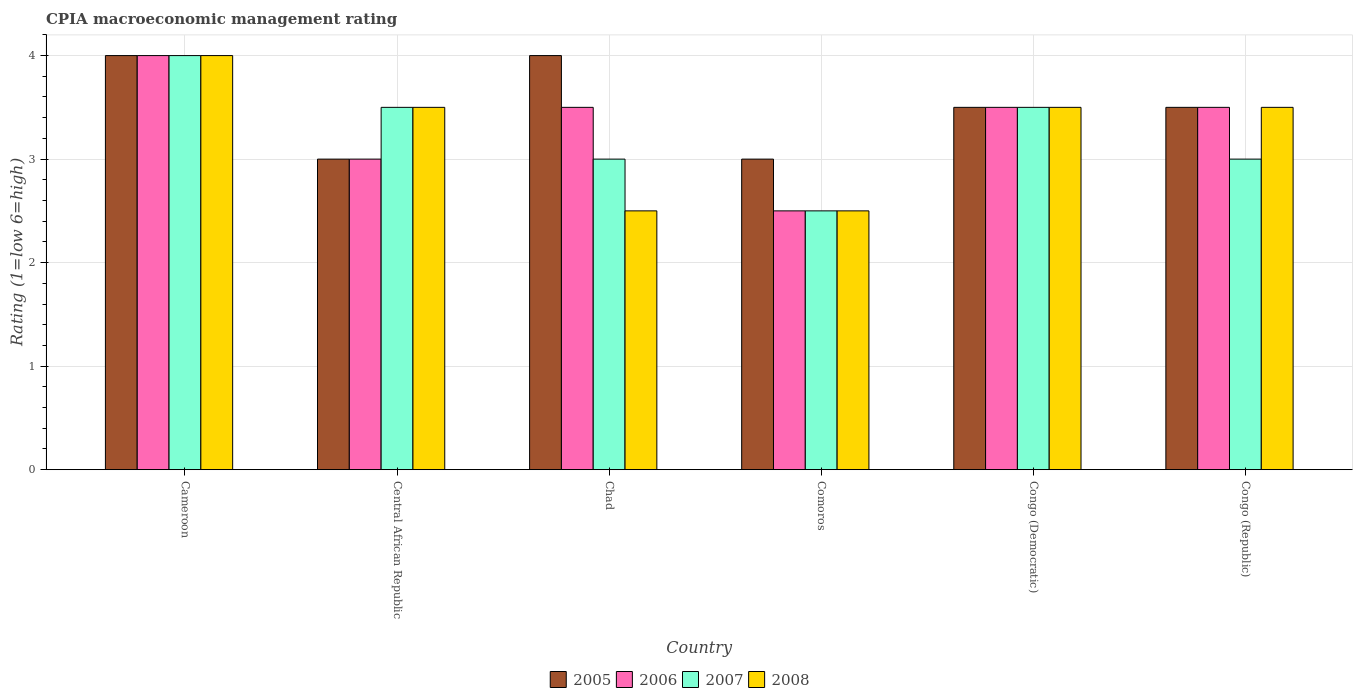How many different coloured bars are there?
Offer a very short reply. 4. Are the number of bars per tick equal to the number of legend labels?
Your answer should be compact. Yes. How many bars are there on the 1st tick from the right?
Offer a very short reply. 4. What is the label of the 3rd group of bars from the left?
Keep it short and to the point. Chad. In how many cases, is the number of bars for a given country not equal to the number of legend labels?
Offer a terse response. 0. What is the CPIA rating in 2006 in Congo (Democratic)?
Provide a short and direct response. 3.5. Across all countries, what is the minimum CPIA rating in 2006?
Provide a succinct answer. 2.5. In which country was the CPIA rating in 2007 maximum?
Give a very brief answer. Cameroon. In which country was the CPIA rating in 2005 minimum?
Your answer should be compact. Central African Republic. What is the total CPIA rating in 2007 in the graph?
Make the answer very short. 19.5. What is the difference between the CPIA rating in 2008 in Cameroon and that in Chad?
Provide a succinct answer. 1.5. What is the difference between the CPIA rating of/in 2008 and CPIA rating of/in 2006 in Central African Republic?
Your answer should be very brief. 0.5. In how many countries, is the CPIA rating in 2006 greater than 2.2?
Keep it short and to the point. 6. What is the ratio of the CPIA rating in 2007 in Chad to that in Congo (Democratic)?
Your response must be concise. 0.86. Is the CPIA rating in 2006 in Chad less than that in Congo (Democratic)?
Make the answer very short. No. What is the difference between the highest and the second highest CPIA rating in 2007?
Offer a very short reply. -0.5. What is the difference between the highest and the lowest CPIA rating in 2005?
Your response must be concise. 1. Is the sum of the CPIA rating in 2007 in Chad and Congo (Democratic) greater than the maximum CPIA rating in 2005 across all countries?
Provide a succinct answer. Yes. How many bars are there?
Give a very brief answer. 24. Are all the bars in the graph horizontal?
Make the answer very short. No. What is the difference between two consecutive major ticks on the Y-axis?
Provide a short and direct response. 1. Does the graph contain grids?
Give a very brief answer. Yes. How are the legend labels stacked?
Make the answer very short. Horizontal. What is the title of the graph?
Make the answer very short. CPIA macroeconomic management rating. What is the Rating (1=low 6=high) of 2008 in Cameroon?
Provide a short and direct response. 4. What is the Rating (1=low 6=high) of 2007 in Central African Republic?
Provide a succinct answer. 3.5. What is the Rating (1=low 6=high) of 2008 in Chad?
Provide a short and direct response. 2.5. What is the Rating (1=low 6=high) of 2008 in Comoros?
Your response must be concise. 2.5. What is the Rating (1=low 6=high) in 2006 in Congo (Democratic)?
Provide a succinct answer. 3.5. What is the Rating (1=low 6=high) in 2007 in Congo (Democratic)?
Offer a very short reply. 3.5. What is the Rating (1=low 6=high) of 2005 in Congo (Republic)?
Offer a terse response. 3.5. What is the Rating (1=low 6=high) in 2006 in Congo (Republic)?
Provide a succinct answer. 3.5. Across all countries, what is the maximum Rating (1=low 6=high) in 2005?
Keep it short and to the point. 4. Across all countries, what is the maximum Rating (1=low 6=high) in 2007?
Give a very brief answer. 4. Across all countries, what is the maximum Rating (1=low 6=high) of 2008?
Give a very brief answer. 4. Across all countries, what is the minimum Rating (1=low 6=high) in 2008?
Your answer should be compact. 2.5. What is the total Rating (1=low 6=high) in 2005 in the graph?
Provide a succinct answer. 21. What is the total Rating (1=low 6=high) in 2006 in the graph?
Make the answer very short. 20. What is the total Rating (1=low 6=high) in 2007 in the graph?
Your response must be concise. 19.5. What is the difference between the Rating (1=low 6=high) of 2005 in Cameroon and that in Central African Republic?
Ensure brevity in your answer.  1. What is the difference between the Rating (1=low 6=high) of 2007 in Cameroon and that in Central African Republic?
Your answer should be very brief. 0.5. What is the difference between the Rating (1=low 6=high) of 2008 in Cameroon and that in Central African Republic?
Ensure brevity in your answer.  0.5. What is the difference between the Rating (1=low 6=high) of 2005 in Cameroon and that in Comoros?
Offer a very short reply. 1. What is the difference between the Rating (1=low 6=high) in 2008 in Cameroon and that in Comoros?
Ensure brevity in your answer.  1.5. What is the difference between the Rating (1=low 6=high) of 2005 in Cameroon and that in Congo (Democratic)?
Offer a very short reply. 0.5. What is the difference between the Rating (1=low 6=high) of 2006 in Cameroon and that in Congo (Democratic)?
Give a very brief answer. 0.5. What is the difference between the Rating (1=low 6=high) of 2007 in Cameroon and that in Congo (Democratic)?
Your response must be concise. 0.5. What is the difference between the Rating (1=low 6=high) of 2008 in Cameroon and that in Congo (Democratic)?
Provide a short and direct response. 0.5. What is the difference between the Rating (1=low 6=high) in 2005 in Cameroon and that in Congo (Republic)?
Keep it short and to the point. 0.5. What is the difference between the Rating (1=low 6=high) of 2008 in Cameroon and that in Congo (Republic)?
Provide a succinct answer. 0.5. What is the difference between the Rating (1=low 6=high) in 2006 in Central African Republic and that in Chad?
Offer a very short reply. -0.5. What is the difference between the Rating (1=low 6=high) of 2008 in Central African Republic and that in Chad?
Make the answer very short. 1. What is the difference between the Rating (1=low 6=high) in 2007 in Central African Republic and that in Comoros?
Provide a succinct answer. 1. What is the difference between the Rating (1=low 6=high) in 2007 in Central African Republic and that in Congo (Democratic)?
Give a very brief answer. 0. What is the difference between the Rating (1=low 6=high) of 2008 in Central African Republic and that in Congo (Democratic)?
Offer a terse response. 0. What is the difference between the Rating (1=low 6=high) of 2005 in Central African Republic and that in Congo (Republic)?
Provide a succinct answer. -0.5. What is the difference between the Rating (1=low 6=high) in 2005 in Chad and that in Comoros?
Make the answer very short. 1. What is the difference between the Rating (1=low 6=high) of 2007 in Chad and that in Comoros?
Ensure brevity in your answer.  0.5. What is the difference between the Rating (1=low 6=high) of 2008 in Chad and that in Comoros?
Your answer should be very brief. 0. What is the difference between the Rating (1=low 6=high) of 2005 in Chad and that in Congo (Democratic)?
Provide a short and direct response. 0.5. What is the difference between the Rating (1=low 6=high) in 2007 in Chad and that in Congo (Democratic)?
Offer a terse response. -0.5. What is the difference between the Rating (1=low 6=high) of 2008 in Chad and that in Congo (Democratic)?
Give a very brief answer. -1. What is the difference between the Rating (1=low 6=high) of 2005 in Chad and that in Congo (Republic)?
Offer a very short reply. 0.5. What is the difference between the Rating (1=low 6=high) of 2007 in Chad and that in Congo (Republic)?
Your answer should be very brief. 0. What is the difference between the Rating (1=low 6=high) in 2008 in Chad and that in Congo (Republic)?
Offer a very short reply. -1. What is the difference between the Rating (1=low 6=high) in 2007 in Comoros and that in Congo (Democratic)?
Keep it short and to the point. -1. What is the difference between the Rating (1=low 6=high) in 2008 in Comoros and that in Congo (Democratic)?
Your answer should be compact. -1. What is the difference between the Rating (1=low 6=high) in 2005 in Comoros and that in Congo (Republic)?
Offer a very short reply. -0.5. What is the difference between the Rating (1=low 6=high) of 2007 in Comoros and that in Congo (Republic)?
Ensure brevity in your answer.  -0.5. What is the difference between the Rating (1=low 6=high) in 2005 in Cameroon and the Rating (1=low 6=high) in 2006 in Central African Republic?
Provide a short and direct response. 1. What is the difference between the Rating (1=low 6=high) of 2005 in Cameroon and the Rating (1=low 6=high) of 2007 in Central African Republic?
Ensure brevity in your answer.  0.5. What is the difference between the Rating (1=low 6=high) of 2006 in Cameroon and the Rating (1=low 6=high) of 2008 in Central African Republic?
Offer a terse response. 0.5. What is the difference between the Rating (1=low 6=high) in 2007 in Cameroon and the Rating (1=low 6=high) in 2008 in Central African Republic?
Keep it short and to the point. 0.5. What is the difference between the Rating (1=low 6=high) in 2005 in Cameroon and the Rating (1=low 6=high) in 2007 in Chad?
Your answer should be compact. 1. What is the difference between the Rating (1=low 6=high) in 2005 in Cameroon and the Rating (1=low 6=high) in 2008 in Chad?
Offer a terse response. 1.5. What is the difference between the Rating (1=low 6=high) of 2006 in Cameroon and the Rating (1=low 6=high) of 2007 in Chad?
Your answer should be very brief. 1. What is the difference between the Rating (1=low 6=high) of 2005 in Cameroon and the Rating (1=low 6=high) of 2006 in Comoros?
Offer a very short reply. 1.5. What is the difference between the Rating (1=low 6=high) of 2005 in Cameroon and the Rating (1=low 6=high) of 2007 in Comoros?
Provide a succinct answer. 1.5. What is the difference between the Rating (1=low 6=high) in 2005 in Cameroon and the Rating (1=low 6=high) in 2007 in Congo (Democratic)?
Offer a terse response. 0.5. What is the difference between the Rating (1=low 6=high) in 2006 in Cameroon and the Rating (1=low 6=high) in 2007 in Congo (Democratic)?
Provide a short and direct response. 0.5. What is the difference between the Rating (1=low 6=high) in 2006 in Cameroon and the Rating (1=low 6=high) in 2008 in Congo (Democratic)?
Keep it short and to the point. 0.5. What is the difference between the Rating (1=low 6=high) of 2007 in Cameroon and the Rating (1=low 6=high) of 2008 in Congo (Democratic)?
Ensure brevity in your answer.  0.5. What is the difference between the Rating (1=low 6=high) in 2005 in Cameroon and the Rating (1=low 6=high) in 2006 in Congo (Republic)?
Make the answer very short. 0.5. What is the difference between the Rating (1=low 6=high) of 2005 in Cameroon and the Rating (1=low 6=high) of 2007 in Congo (Republic)?
Ensure brevity in your answer.  1. What is the difference between the Rating (1=low 6=high) in 2006 in Cameroon and the Rating (1=low 6=high) in 2007 in Congo (Republic)?
Make the answer very short. 1. What is the difference between the Rating (1=low 6=high) of 2007 in Cameroon and the Rating (1=low 6=high) of 2008 in Congo (Republic)?
Offer a very short reply. 0.5. What is the difference between the Rating (1=low 6=high) of 2005 in Central African Republic and the Rating (1=low 6=high) of 2006 in Chad?
Give a very brief answer. -0.5. What is the difference between the Rating (1=low 6=high) of 2005 in Central African Republic and the Rating (1=low 6=high) of 2007 in Chad?
Keep it short and to the point. 0. What is the difference between the Rating (1=low 6=high) of 2005 in Central African Republic and the Rating (1=low 6=high) of 2008 in Chad?
Make the answer very short. 0.5. What is the difference between the Rating (1=low 6=high) of 2006 in Central African Republic and the Rating (1=low 6=high) of 2007 in Chad?
Provide a short and direct response. 0. What is the difference between the Rating (1=low 6=high) in 2006 in Central African Republic and the Rating (1=low 6=high) in 2008 in Chad?
Your answer should be very brief. 0.5. What is the difference between the Rating (1=low 6=high) of 2007 in Central African Republic and the Rating (1=low 6=high) of 2008 in Chad?
Your answer should be very brief. 1. What is the difference between the Rating (1=low 6=high) in 2005 in Central African Republic and the Rating (1=low 6=high) in 2006 in Comoros?
Ensure brevity in your answer.  0.5. What is the difference between the Rating (1=low 6=high) of 2005 in Central African Republic and the Rating (1=low 6=high) of 2008 in Comoros?
Give a very brief answer. 0.5. What is the difference between the Rating (1=low 6=high) in 2006 in Central African Republic and the Rating (1=low 6=high) in 2007 in Comoros?
Provide a succinct answer. 0.5. What is the difference between the Rating (1=low 6=high) of 2007 in Central African Republic and the Rating (1=low 6=high) of 2008 in Comoros?
Offer a very short reply. 1. What is the difference between the Rating (1=low 6=high) of 2005 in Central African Republic and the Rating (1=low 6=high) of 2006 in Congo (Democratic)?
Give a very brief answer. -0.5. What is the difference between the Rating (1=low 6=high) of 2005 in Central African Republic and the Rating (1=low 6=high) of 2007 in Congo (Democratic)?
Offer a very short reply. -0.5. What is the difference between the Rating (1=low 6=high) in 2005 in Central African Republic and the Rating (1=low 6=high) in 2008 in Congo (Democratic)?
Your answer should be compact. -0.5. What is the difference between the Rating (1=low 6=high) of 2006 in Central African Republic and the Rating (1=low 6=high) of 2008 in Congo (Democratic)?
Provide a succinct answer. -0.5. What is the difference between the Rating (1=low 6=high) in 2005 in Central African Republic and the Rating (1=low 6=high) in 2008 in Congo (Republic)?
Give a very brief answer. -0.5. What is the difference between the Rating (1=low 6=high) in 2007 in Central African Republic and the Rating (1=low 6=high) in 2008 in Congo (Republic)?
Ensure brevity in your answer.  0. What is the difference between the Rating (1=low 6=high) in 2005 in Chad and the Rating (1=low 6=high) in 2006 in Congo (Republic)?
Keep it short and to the point. 0.5. What is the difference between the Rating (1=low 6=high) in 2005 in Chad and the Rating (1=low 6=high) in 2007 in Congo (Republic)?
Offer a terse response. 1. What is the difference between the Rating (1=low 6=high) in 2005 in Chad and the Rating (1=low 6=high) in 2008 in Congo (Republic)?
Ensure brevity in your answer.  0.5. What is the difference between the Rating (1=low 6=high) of 2006 in Chad and the Rating (1=low 6=high) of 2007 in Congo (Republic)?
Your answer should be very brief. 0.5. What is the difference between the Rating (1=low 6=high) of 2007 in Chad and the Rating (1=low 6=high) of 2008 in Congo (Republic)?
Give a very brief answer. -0.5. What is the difference between the Rating (1=low 6=high) in 2005 in Comoros and the Rating (1=low 6=high) in 2008 in Congo (Democratic)?
Your response must be concise. -0.5. What is the difference between the Rating (1=low 6=high) of 2006 in Comoros and the Rating (1=low 6=high) of 2008 in Congo (Democratic)?
Provide a succinct answer. -1. What is the difference between the Rating (1=low 6=high) of 2005 in Comoros and the Rating (1=low 6=high) of 2006 in Congo (Republic)?
Your answer should be compact. -0.5. What is the difference between the Rating (1=low 6=high) in 2005 in Comoros and the Rating (1=low 6=high) in 2007 in Congo (Republic)?
Make the answer very short. 0. What is the difference between the Rating (1=low 6=high) in 2006 in Comoros and the Rating (1=low 6=high) in 2007 in Congo (Republic)?
Offer a very short reply. -0.5. What is the difference between the Rating (1=low 6=high) in 2006 in Comoros and the Rating (1=low 6=high) in 2008 in Congo (Republic)?
Provide a succinct answer. -1. What is the difference between the Rating (1=low 6=high) of 2005 in Congo (Democratic) and the Rating (1=low 6=high) of 2008 in Congo (Republic)?
Your response must be concise. 0. What is the difference between the Rating (1=low 6=high) of 2007 in Congo (Democratic) and the Rating (1=low 6=high) of 2008 in Congo (Republic)?
Offer a terse response. 0. What is the average Rating (1=low 6=high) in 2005 per country?
Give a very brief answer. 3.5. What is the average Rating (1=low 6=high) in 2006 per country?
Ensure brevity in your answer.  3.33. What is the average Rating (1=low 6=high) of 2007 per country?
Your response must be concise. 3.25. What is the average Rating (1=low 6=high) in 2008 per country?
Keep it short and to the point. 3.25. What is the difference between the Rating (1=low 6=high) of 2005 and Rating (1=low 6=high) of 2007 in Cameroon?
Give a very brief answer. 0. What is the difference between the Rating (1=low 6=high) of 2006 and Rating (1=low 6=high) of 2008 in Cameroon?
Provide a short and direct response. 0. What is the difference between the Rating (1=low 6=high) in 2007 and Rating (1=low 6=high) in 2008 in Cameroon?
Give a very brief answer. 0. What is the difference between the Rating (1=low 6=high) of 2006 and Rating (1=low 6=high) of 2008 in Central African Republic?
Your response must be concise. -0.5. What is the difference between the Rating (1=low 6=high) in 2007 and Rating (1=low 6=high) in 2008 in Central African Republic?
Offer a very short reply. 0. What is the difference between the Rating (1=low 6=high) in 2005 and Rating (1=low 6=high) in 2006 in Chad?
Offer a very short reply. 0.5. What is the difference between the Rating (1=low 6=high) in 2005 and Rating (1=low 6=high) in 2007 in Chad?
Offer a terse response. 1. What is the difference between the Rating (1=low 6=high) in 2005 and Rating (1=low 6=high) in 2008 in Chad?
Provide a short and direct response. 1.5. What is the difference between the Rating (1=low 6=high) of 2006 and Rating (1=low 6=high) of 2007 in Chad?
Your answer should be very brief. 0.5. What is the difference between the Rating (1=low 6=high) in 2006 and Rating (1=low 6=high) in 2008 in Chad?
Make the answer very short. 1. What is the difference between the Rating (1=low 6=high) of 2007 and Rating (1=low 6=high) of 2008 in Chad?
Ensure brevity in your answer.  0.5. What is the difference between the Rating (1=low 6=high) in 2005 and Rating (1=low 6=high) in 2006 in Comoros?
Keep it short and to the point. 0.5. What is the difference between the Rating (1=low 6=high) in 2005 and Rating (1=low 6=high) in 2007 in Comoros?
Your answer should be compact. 0.5. What is the difference between the Rating (1=low 6=high) in 2006 and Rating (1=low 6=high) in 2008 in Comoros?
Give a very brief answer. 0. What is the difference between the Rating (1=low 6=high) of 2007 and Rating (1=low 6=high) of 2008 in Comoros?
Offer a terse response. 0. What is the difference between the Rating (1=low 6=high) of 2005 and Rating (1=low 6=high) of 2008 in Congo (Democratic)?
Offer a very short reply. 0. What is the difference between the Rating (1=low 6=high) of 2006 and Rating (1=low 6=high) of 2007 in Congo (Democratic)?
Offer a very short reply. 0. What is the difference between the Rating (1=low 6=high) of 2006 and Rating (1=low 6=high) of 2008 in Congo (Democratic)?
Give a very brief answer. 0. What is the difference between the Rating (1=low 6=high) of 2005 and Rating (1=low 6=high) of 2007 in Congo (Republic)?
Your response must be concise. 0.5. What is the difference between the Rating (1=low 6=high) in 2006 and Rating (1=low 6=high) in 2008 in Congo (Republic)?
Offer a terse response. 0. What is the difference between the Rating (1=low 6=high) in 2007 and Rating (1=low 6=high) in 2008 in Congo (Republic)?
Keep it short and to the point. -0.5. What is the ratio of the Rating (1=low 6=high) in 2006 in Cameroon to that in Central African Republic?
Your answer should be compact. 1.33. What is the ratio of the Rating (1=low 6=high) in 2006 in Cameroon to that in Chad?
Make the answer very short. 1.14. What is the ratio of the Rating (1=low 6=high) in 2005 in Cameroon to that in Comoros?
Provide a short and direct response. 1.33. What is the ratio of the Rating (1=low 6=high) of 2008 in Cameroon to that in Comoros?
Make the answer very short. 1.6. What is the ratio of the Rating (1=low 6=high) in 2005 in Cameroon to that in Congo (Democratic)?
Provide a short and direct response. 1.14. What is the ratio of the Rating (1=low 6=high) of 2006 in Cameroon to that in Congo (Democratic)?
Your response must be concise. 1.14. What is the ratio of the Rating (1=low 6=high) of 2007 in Cameroon to that in Congo (Democratic)?
Provide a succinct answer. 1.14. What is the ratio of the Rating (1=low 6=high) in 2008 in Cameroon to that in Congo (Democratic)?
Give a very brief answer. 1.14. What is the ratio of the Rating (1=low 6=high) in 2006 in Cameroon to that in Congo (Republic)?
Your answer should be very brief. 1.14. What is the ratio of the Rating (1=low 6=high) of 2007 in Cameroon to that in Congo (Republic)?
Give a very brief answer. 1.33. What is the ratio of the Rating (1=low 6=high) in 2008 in Cameroon to that in Congo (Republic)?
Give a very brief answer. 1.14. What is the ratio of the Rating (1=low 6=high) of 2005 in Central African Republic to that in Chad?
Your response must be concise. 0.75. What is the ratio of the Rating (1=low 6=high) of 2006 in Central African Republic to that in Chad?
Make the answer very short. 0.86. What is the ratio of the Rating (1=low 6=high) in 2008 in Central African Republic to that in Chad?
Offer a terse response. 1.4. What is the ratio of the Rating (1=low 6=high) in 2007 in Central African Republic to that in Comoros?
Your answer should be very brief. 1.4. What is the ratio of the Rating (1=low 6=high) of 2008 in Central African Republic to that in Comoros?
Your response must be concise. 1.4. What is the ratio of the Rating (1=low 6=high) of 2005 in Central African Republic to that in Congo (Democratic)?
Provide a succinct answer. 0.86. What is the ratio of the Rating (1=low 6=high) of 2008 in Central African Republic to that in Congo (Democratic)?
Keep it short and to the point. 1. What is the ratio of the Rating (1=low 6=high) of 2005 in Central African Republic to that in Congo (Republic)?
Ensure brevity in your answer.  0.86. What is the ratio of the Rating (1=low 6=high) of 2006 in Central African Republic to that in Congo (Republic)?
Keep it short and to the point. 0.86. What is the ratio of the Rating (1=low 6=high) of 2005 in Chad to that in Comoros?
Your answer should be compact. 1.33. What is the ratio of the Rating (1=low 6=high) in 2006 in Chad to that in Comoros?
Keep it short and to the point. 1.4. What is the ratio of the Rating (1=low 6=high) in 2005 in Chad to that in Congo (Democratic)?
Your answer should be very brief. 1.14. What is the ratio of the Rating (1=low 6=high) of 2007 in Chad to that in Congo (Democratic)?
Keep it short and to the point. 0.86. What is the ratio of the Rating (1=low 6=high) of 2008 in Chad to that in Congo (Democratic)?
Provide a succinct answer. 0.71. What is the ratio of the Rating (1=low 6=high) of 2005 in Chad to that in Congo (Republic)?
Provide a short and direct response. 1.14. What is the ratio of the Rating (1=low 6=high) in 2006 in Chad to that in Congo (Republic)?
Provide a succinct answer. 1. What is the ratio of the Rating (1=low 6=high) of 2007 in Chad to that in Congo (Republic)?
Your answer should be very brief. 1. What is the ratio of the Rating (1=low 6=high) of 2007 in Comoros to that in Congo (Democratic)?
Make the answer very short. 0.71. What is the ratio of the Rating (1=low 6=high) of 2008 in Comoros to that in Congo (Democratic)?
Give a very brief answer. 0.71. What is the ratio of the Rating (1=low 6=high) in 2005 in Comoros to that in Congo (Republic)?
Give a very brief answer. 0.86. What is the ratio of the Rating (1=low 6=high) in 2006 in Comoros to that in Congo (Republic)?
Offer a terse response. 0.71. What is the ratio of the Rating (1=low 6=high) of 2007 in Comoros to that in Congo (Republic)?
Offer a terse response. 0.83. What is the ratio of the Rating (1=low 6=high) of 2008 in Comoros to that in Congo (Republic)?
Keep it short and to the point. 0.71. What is the ratio of the Rating (1=low 6=high) of 2006 in Congo (Democratic) to that in Congo (Republic)?
Your response must be concise. 1. What is the ratio of the Rating (1=low 6=high) in 2007 in Congo (Democratic) to that in Congo (Republic)?
Provide a succinct answer. 1.17. What is the ratio of the Rating (1=low 6=high) of 2008 in Congo (Democratic) to that in Congo (Republic)?
Provide a succinct answer. 1. What is the difference between the highest and the second highest Rating (1=low 6=high) in 2005?
Make the answer very short. 0. What is the difference between the highest and the second highest Rating (1=low 6=high) in 2007?
Provide a succinct answer. 0.5. What is the difference between the highest and the second highest Rating (1=low 6=high) in 2008?
Your response must be concise. 0.5. What is the difference between the highest and the lowest Rating (1=low 6=high) in 2005?
Provide a short and direct response. 1. What is the difference between the highest and the lowest Rating (1=low 6=high) in 2006?
Offer a terse response. 1.5. What is the difference between the highest and the lowest Rating (1=low 6=high) of 2008?
Make the answer very short. 1.5. 